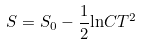Convert formula to latex. <formula><loc_0><loc_0><loc_500><loc_500>S = S _ { 0 } - \frac { 1 } { 2 } { \ln } C T ^ { 2 }</formula> 